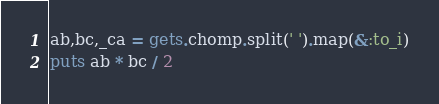Convert code to text. <code><loc_0><loc_0><loc_500><loc_500><_Ruby_>ab,bc,_ca = gets.chomp.split(' ').map(&:to_i)
puts ab * bc / 2</code> 